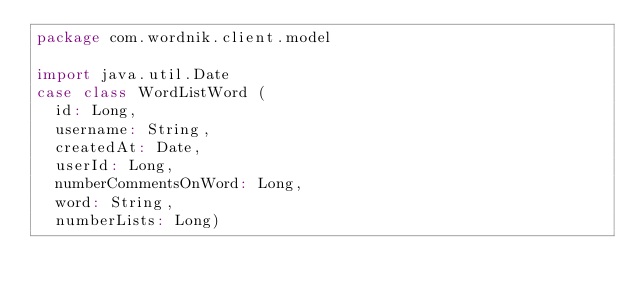<code> <loc_0><loc_0><loc_500><loc_500><_Scala_>package com.wordnik.client.model

import java.util.Date
case class WordListWord (
  id: Long,
  username: String,
  createdAt: Date,
  userId: Long,
  numberCommentsOnWord: Long,
  word: String,
  numberLists: Long)

</code> 